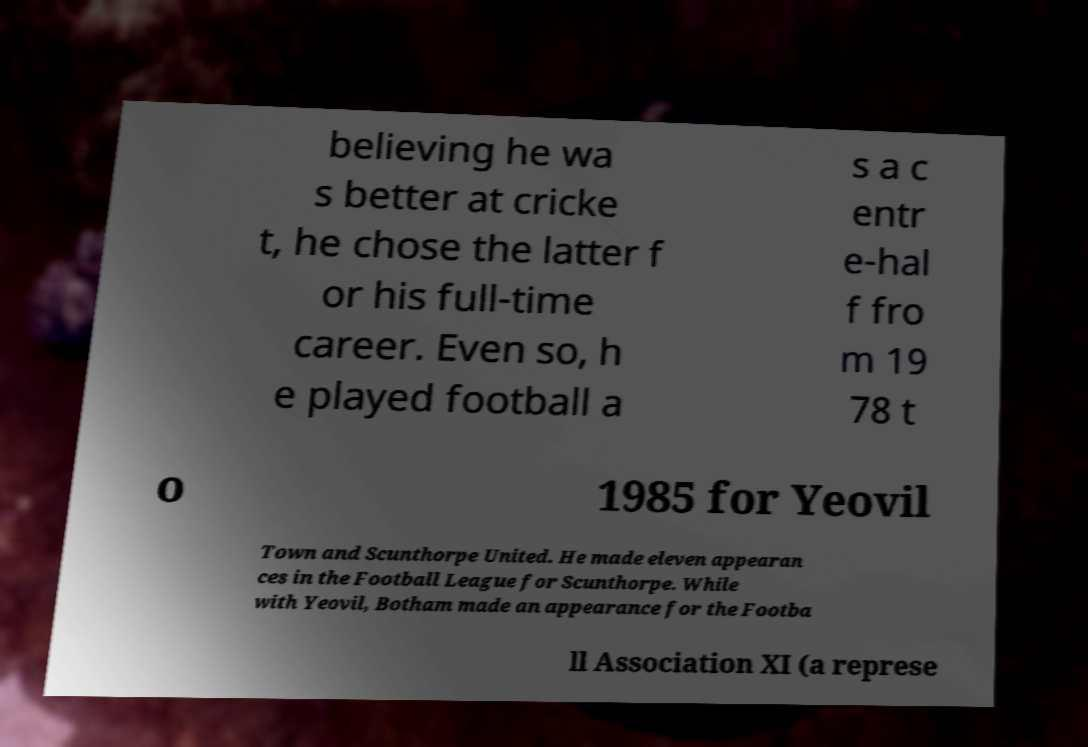Can you accurately transcribe the text from the provided image for me? believing he wa s better at cricke t, he chose the latter f or his full-time career. Even so, h e played football a s a c entr e-hal f fro m 19 78 t o 1985 for Yeovil Town and Scunthorpe United. He made eleven appearan ces in the Football League for Scunthorpe. While with Yeovil, Botham made an appearance for the Footba ll Association XI (a represe 